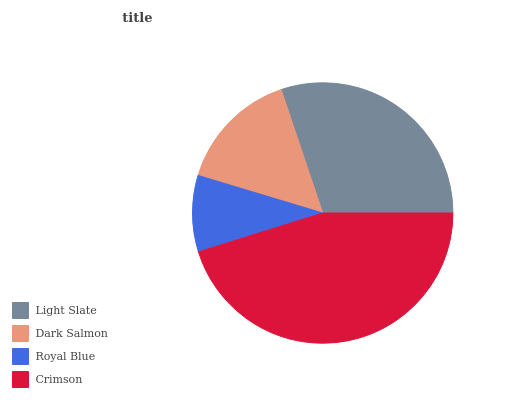Is Royal Blue the minimum?
Answer yes or no. Yes. Is Crimson the maximum?
Answer yes or no. Yes. Is Dark Salmon the minimum?
Answer yes or no. No. Is Dark Salmon the maximum?
Answer yes or no. No. Is Light Slate greater than Dark Salmon?
Answer yes or no. Yes. Is Dark Salmon less than Light Slate?
Answer yes or no. Yes. Is Dark Salmon greater than Light Slate?
Answer yes or no. No. Is Light Slate less than Dark Salmon?
Answer yes or no. No. Is Light Slate the high median?
Answer yes or no. Yes. Is Dark Salmon the low median?
Answer yes or no. Yes. Is Crimson the high median?
Answer yes or no. No. Is Crimson the low median?
Answer yes or no. No. 